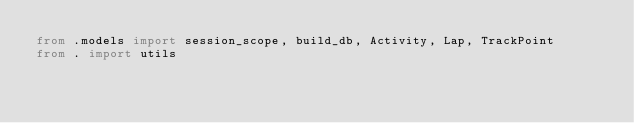Convert code to text. <code><loc_0><loc_0><loc_500><loc_500><_Python_>from .models import session_scope, build_db, Activity, Lap, TrackPoint
from . import utils
</code> 